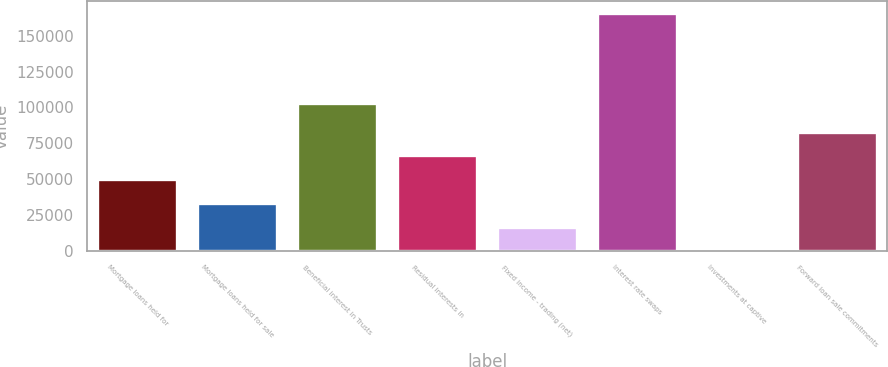<chart> <loc_0><loc_0><loc_500><loc_500><bar_chart><fcel>Mortgage loans held for<fcel>Mortgage loans held for sale<fcel>Beneficial interest in Trusts<fcel>Residual interests in<fcel>Fixed income - trading (net)<fcel>Interest rate swaps<fcel>Investments at captive<fcel>Forward loan sale commitments<nl><fcel>49997.7<fcel>33455.8<fcel>103365<fcel>66539.6<fcel>16913.9<fcel>165791<fcel>372<fcel>83081.5<nl></chart> 